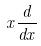Convert formula to latex. <formula><loc_0><loc_0><loc_500><loc_500>x \frac { d } { d x }</formula> 